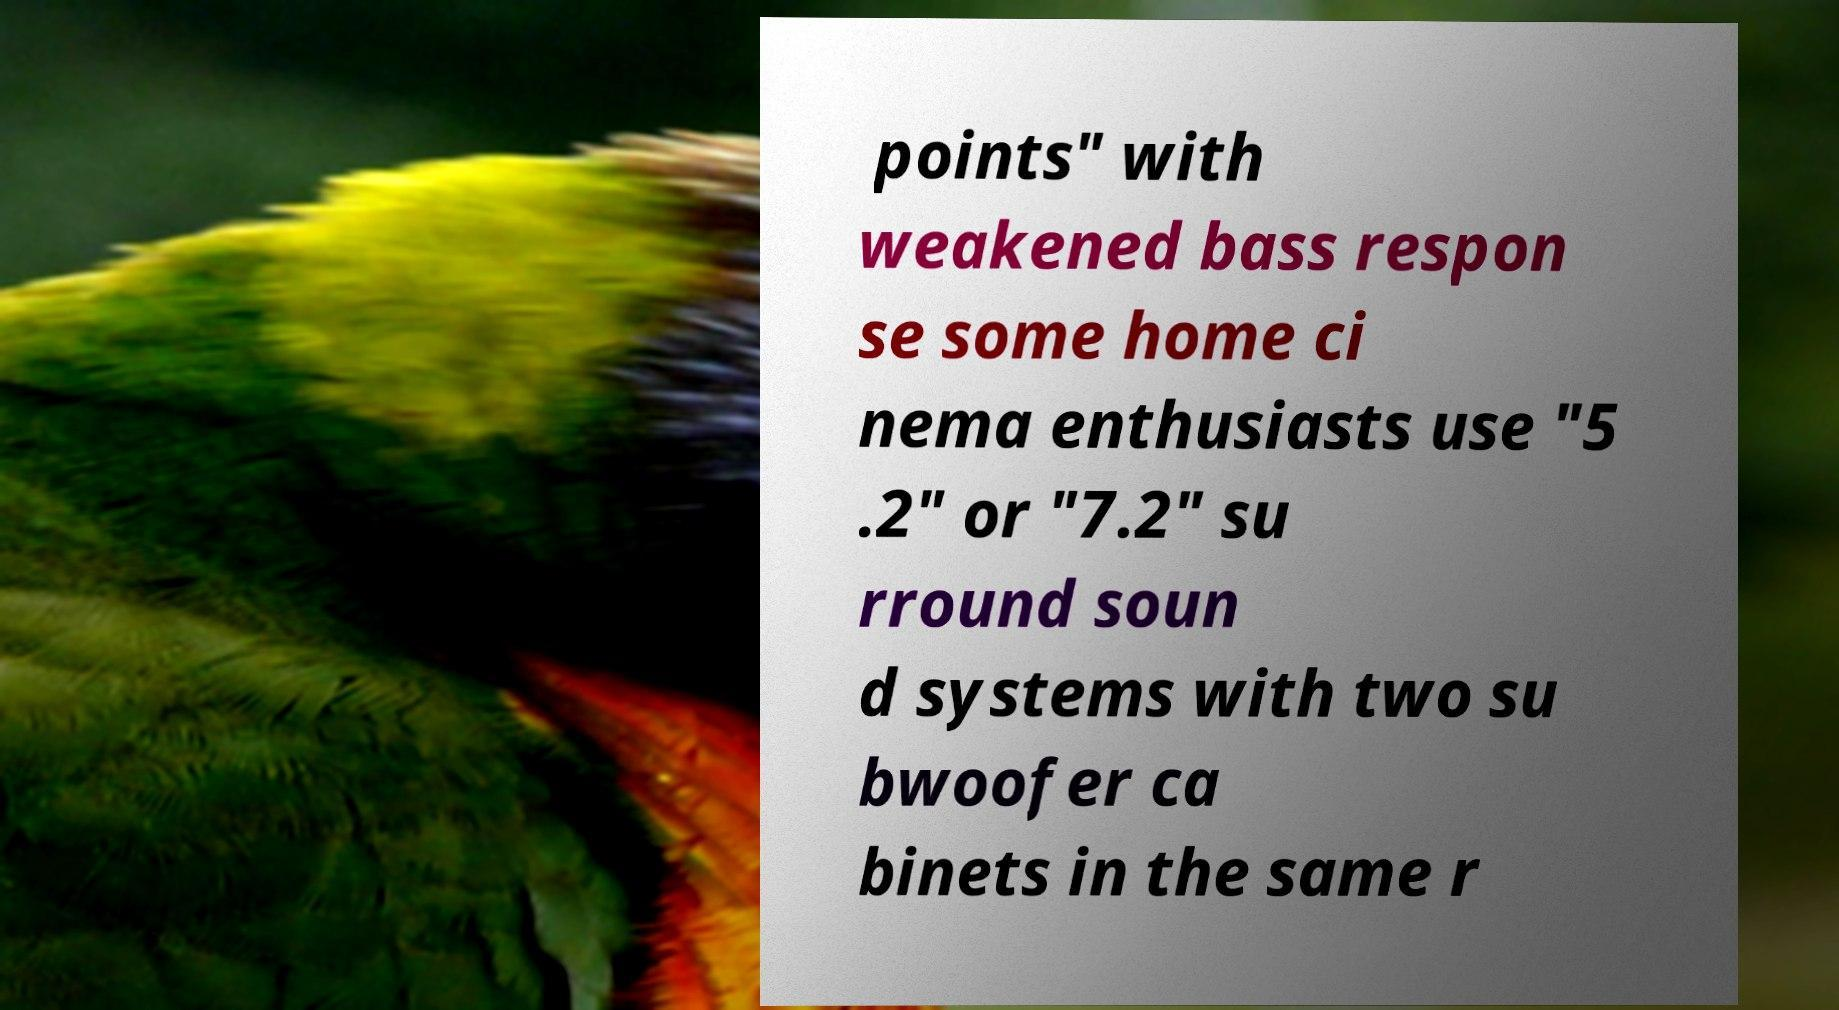Could you extract and type out the text from this image? points" with weakened bass respon se some home ci nema enthusiasts use "5 .2" or "7.2" su rround soun d systems with two su bwoofer ca binets in the same r 